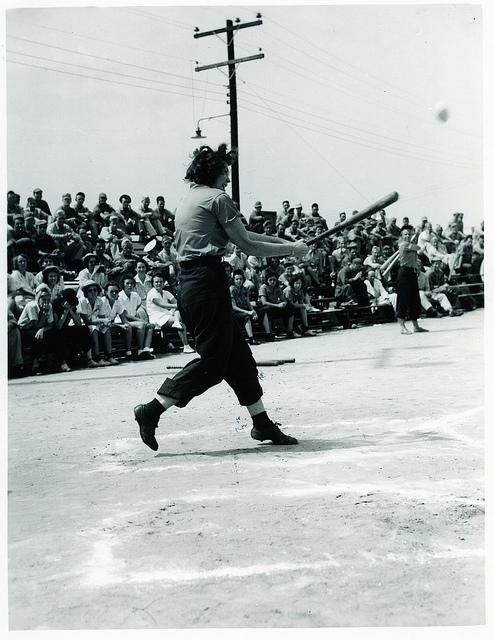What sport are these women most likely playing? Please explain your reasoning. softball. They have a bat and women usually play this instead of baseball 